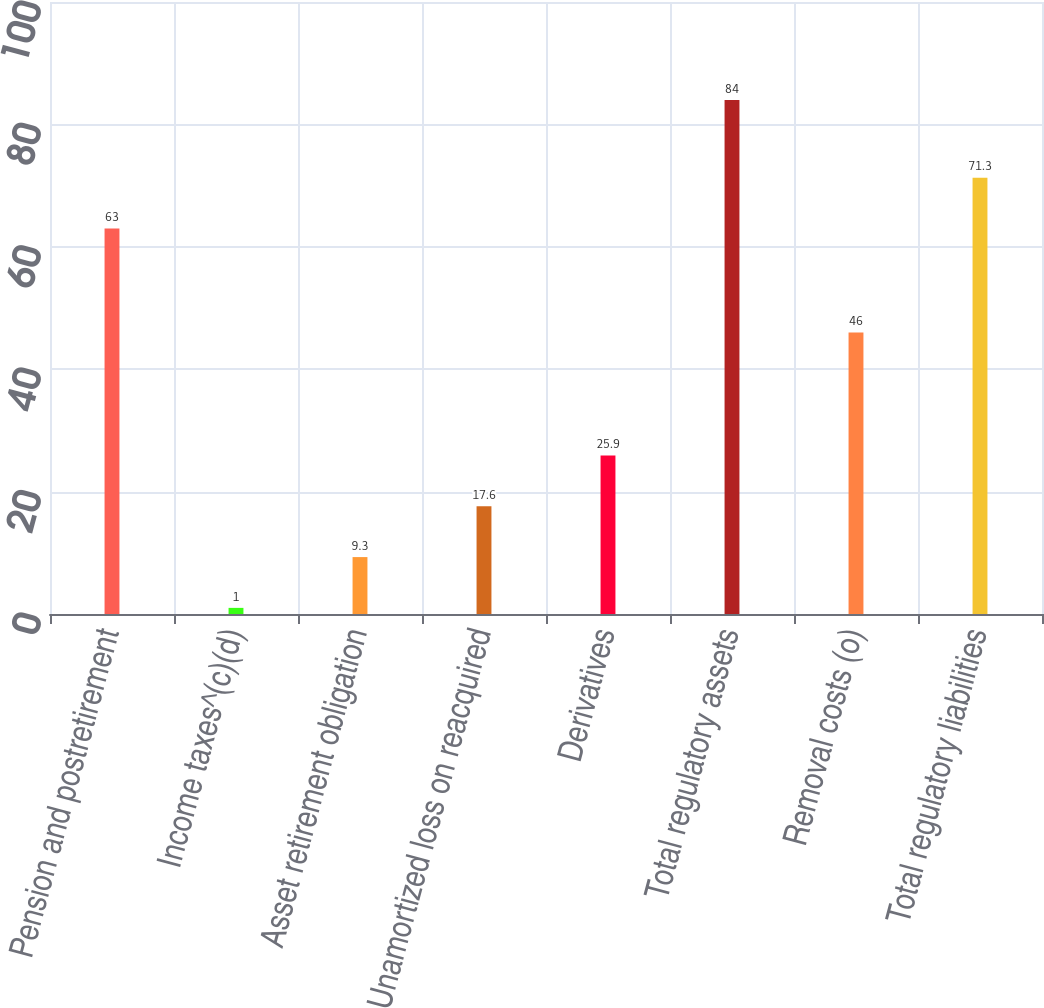Convert chart. <chart><loc_0><loc_0><loc_500><loc_500><bar_chart><fcel>Pension and postretirement<fcel>Income taxes^(c)(d)<fcel>Asset retirement obligation<fcel>Unamortized loss on reacquired<fcel>Derivatives<fcel>Total regulatory assets<fcel>Removal costs (o)<fcel>Total regulatory liabilities<nl><fcel>63<fcel>1<fcel>9.3<fcel>17.6<fcel>25.9<fcel>84<fcel>46<fcel>71.3<nl></chart> 